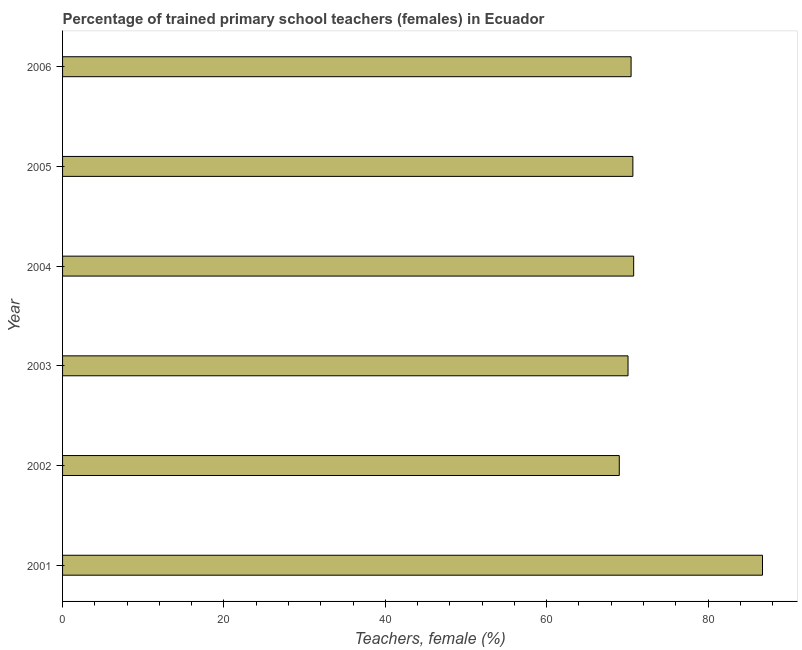Does the graph contain any zero values?
Keep it short and to the point. No. Does the graph contain grids?
Keep it short and to the point. No. What is the title of the graph?
Make the answer very short. Percentage of trained primary school teachers (females) in Ecuador. What is the label or title of the X-axis?
Keep it short and to the point. Teachers, female (%). What is the percentage of trained female teachers in 2005?
Give a very brief answer. 70.69. Across all years, what is the maximum percentage of trained female teachers?
Offer a very short reply. 86.75. Across all years, what is the minimum percentage of trained female teachers?
Your answer should be very brief. 69. In which year was the percentage of trained female teachers maximum?
Offer a very short reply. 2001. In which year was the percentage of trained female teachers minimum?
Offer a very short reply. 2002. What is the sum of the percentage of trained female teachers?
Make the answer very short. 437.77. What is the difference between the percentage of trained female teachers in 2002 and 2005?
Provide a short and direct response. -1.69. What is the average percentage of trained female teachers per year?
Provide a succinct answer. 72.96. What is the median percentage of trained female teachers?
Offer a very short reply. 70.58. Do a majority of the years between 2002 and 2003 (inclusive) have percentage of trained female teachers greater than 76 %?
Offer a very short reply. No. What is the ratio of the percentage of trained female teachers in 2001 to that in 2005?
Your response must be concise. 1.23. Is the difference between the percentage of trained female teachers in 2005 and 2006 greater than the difference between any two years?
Ensure brevity in your answer.  No. What is the difference between the highest and the second highest percentage of trained female teachers?
Make the answer very short. 15.97. Is the sum of the percentage of trained female teachers in 2004 and 2005 greater than the maximum percentage of trained female teachers across all years?
Make the answer very short. Yes. What is the difference between the highest and the lowest percentage of trained female teachers?
Make the answer very short. 17.75. How many years are there in the graph?
Provide a succinct answer. 6. What is the Teachers, female (%) in 2001?
Keep it short and to the point. 86.75. What is the Teachers, female (%) of 2002?
Give a very brief answer. 69. What is the Teachers, female (%) in 2003?
Your response must be concise. 70.08. What is the Teachers, female (%) of 2004?
Make the answer very short. 70.78. What is the Teachers, female (%) in 2005?
Ensure brevity in your answer.  70.69. What is the Teachers, female (%) in 2006?
Your answer should be very brief. 70.46. What is the difference between the Teachers, female (%) in 2001 and 2002?
Your answer should be compact. 17.75. What is the difference between the Teachers, female (%) in 2001 and 2003?
Give a very brief answer. 16.67. What is the difference between the Teachers, female (%) in 2001 and 2004?
Your answer should be compact. 15.97. What is the difference between the Teachers, female (%) in 2001 and 2005?
Make the answer very short. 16.06. What is the difference between the Teachers, female (%) in 2001 and 2006?
Keep it short and to the point. 16.29. What is the difference between the Teachers, female (%) in 2002 and 2003?
Provide a succinct answer. -1.08. What is the difference between the Teachers, female (%) in 2002 and 2004?
Your response must be concise. -1.78. What is the difference between the Teachers, female (%) in 2002 and 2005?
Offer a very short reply. -1.69. What is the difference between the Teachers, female (%) in 2002 and 2006?
Provide a succinct answer. -1.46. What is the difference between the Teachers, female (%) in 2003 and 2004?
Offer a terse response. -0.7. What is the difference between the Teachers, female (%) in 2003 and 2005?
Give a very brief answer. -0.6. What is the difference between the Teachers, female (%) in 2003 and 2006?
Your response must be concise. -0.38. What is the difference between the Teachers, female (%) in 2004 and 2005?
Offer a terse response. 0.1. What is the difference between the Teachers, female (%) in 2004 and 2006?
Your answer should be compact. 0.32. What is the difference between the Teachers, female (%) in 2005 and 2006?
Your answer should be compact. 0.22. What is the ratio of the Teachers, female (%) in 2001 to that in 2002?
Offer a terse response. 1.26. What is the ratio of the Teachers, female (%) in 2001 to that in 2003?
Offer a very short reply. 1.24. What is the ratio of the Teachers, female (%) in 2001 to that in 2004?
Provide a succinct answer. 1.23. What is the ratio of the Teachers, female (%) in 2001 to that in 2005?
Your response must be concise. 1.23. What is the ratio of the Teachers, female (%) in 2001 to that in 2006?
Keep it short and to the point. 1.23. What is the ratio of the Teachers, female (%) in 2002 to that in 2004?
Offer a terse response. 0.97. What is the ratio of the Teachers, female (%) in 2003 to that in 2004?
Make the answer very short. 0.99. What is the ratio of the Teachers, female (%) in 2003 to that in 2006?
Make the answer very short. 0.99. What is the ratio of the Teachers, female (%) in 2004 to that in 2006?
Give a very brief answer. 1. What is the ratio of the Teachers, female (%) in 2005 to that in 2006?
Provide a short and direct response. 1. 